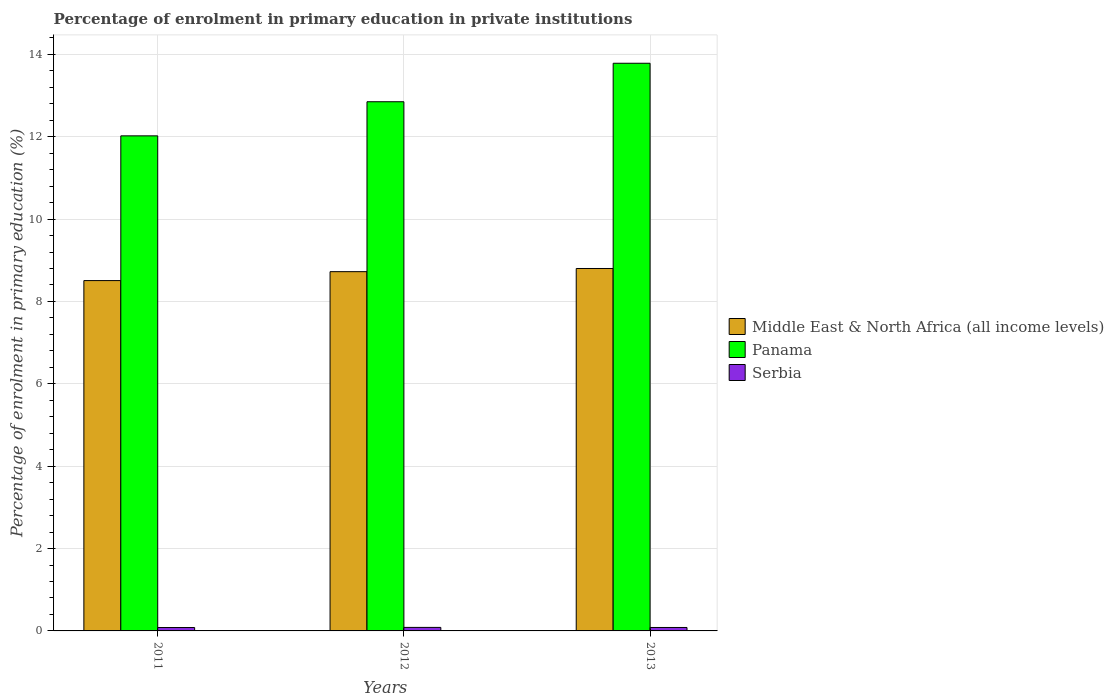How many different coloured bars are there?
Offer a terse response. 3. How many groups of bars are there?
Your answer should be compact. 3. Are the number of bars per tick equal to the number of legend labels?
Your answer should be very brief. Yes. Are the number of bars on each tick of the X-axis equal?
Your answer should be very brief. Yes. How many bars are there on the 1st tick from the left?
Your answer should be compact. 3. What is the label of the 1st group of bars from the left?
Keep it short and to the point. 2011. What is the percentage of enrolment in primary education in Middle East & North Africa (all income levels) in 2012?
Make the answer very short. 8.72. Across all years, what is the maximum percentage of enrolment in primary education in Serbia?
Offer a very short reply. 0.09. Across all years, what is the minimum percentage of enrolment in primary education in Serbia?
Ensure brevity in your answer.  0.08. In which year was the percentage of enrolment in primary education in Serbia minimum?
Offer a terse response. 2011. What is the total percentage of enrolment in primary education in Middle East & North Africa (all income levels) in the graph?
Give a very brief answer. 26.03. What is the difference between the percentage of enrolment in primary education in Middle East & North Africa (all income levels) in 2011 and that in 2013?
Offer a terse response. -0.29. What is the difference between the percentage of enrolment in primary education in Middle East & North Africa (all income levels) in 2011 and the percentage of enrolment in primary education in Serbia in 2012?
Make the answer very short. 8.42. What is the average percentage of enrolment in primary education in Middle East & North Africa (all income levels) per year?
Provide a short and direct response. 8.68. In the year 2013, what is the difference between the percentage of enrolment in primary education in Panama and percentage of enrolment in primary education in Serbia?
Provide a succinct answer. 13.7. In how many years, is the percentage of enrolment in primary education in Middle East & North Africa (all income levels) greater than 2 %?
Ensure brevity in your answer.  3. What is the ratio of the percentage of enrolment in primary education in Serbia in 2012 to that in 2013?
Offer a terse response. 1.02. Is the percentage of enrolment in primary education in Serbia in 2011 less than that in 2013?
Your answer should be compact. Yes. What is the difference between the highest and the second highest percentage of enrolment in primary education in Middle East & North Africa (all income levels)?
Provide a succinct answer. 0.08. What is the difference between the highest and the lowest percentage of enrolment in primary education in Panama?
Provide a short and direct response. 1.76. What does the 1st bar from the left in 2013 represents?
Offer a terse response. Middle East & North Africa (all income levels). What does the 1st bar from the right in 2011 represents?
Make the answer very short. Serbia. Is it the case that in every year, the sum of the percentage of enrolment in primary education in Middle East & North Africa (all income levels) and percentage of enrolment in primary education in Serbia is greater than the percentage of enrolment in primary education in Panama?
Your answer should be very brief. No. How many bars are there?
Your answer should be compact. 9. Are all the bars in the graph horizontal?
Give a very brief answer. No. Are the values on the major ticks of Y-axis written in scientific E-notation?
Make the answer very short. No. Does the graph contain grids?
Offer a very short reply. Yes. How many legend labels are there?
Provide a succinct answer. 3. What is the title of the graph?
Offer a terse response. Percentage of enrolment in primary education in private institutions. What is the label or title of the X-axis?
Provide a short and direct response. Years. What is the label or title of the Y-axis?
Provide a short and direct response. Percentage of enrolment in primary education (%). What is the Percentage of enrolment in primary education (%) in Middle East & North Africa (all income levels) in 2011?
Keep it short and to the point. 8.51. What is the Percentage of enrolment in primary education (%) of Panama in 2011?
Provide a short and direct response. 12.02. What is the Percentage of enrolment in primary education (%) in Serbia in 2011?
Give a very brief answer. 0.08. What is the Percentage of enrolment in primary education (%) in Middle East & North Africa (all income levels) in 2012?
Provide a short and direct response. 8.72. What is the Percentage of enrolment in primary education (%) in Panama in 2012?
Offer a very short reply. 12.85. What is the Percentage of enrolment in primary education (%) of Serbia in 2012?
Your answer should be compact. 0.09. What is the Percentage of enrolment in primary education (%) in Middle East & North Africa (all income levels) in 2013?
Make the answer very short. 8.8. What is the Percentage of enrolment in primary education (%) of Panama in 2013?
Your response must be concise. 13.78. What is the Percentage of enrolment in primary education (%) of Serbia in 2013?
Keep it short and to the point. 0.08. Across all years, what is the maximum Percentage of enrolment in primary education (%) in Middle East & North Africa (all income levels)?
Ensure brevity in your answer.  8.8. Across all years, what is the maximum Percentage of enrolment in primary education (%) in Panama?
Your response must be concise. 13.78. Across all years, what is the maximum Percentage of enrolment in primary education (%) of Serbia?
Your answer should be compact. 0.09. Across all years, what is the minimum Percentage of enrolment in primary education (%) in Middle East & North Africa (all income levels)?
Make the answer very short. 8.51. Across all years, what is the minimum Percentage of enrolment in primary education (%) in Panama?
Your response must be concise. 12.02. Across all years, what is the minimum Percentage of enrolment in primary education (%) in Serbia?
Provide a succinct answer. 0.08. What is the total Percentage of enrolment in primary education (%) in Middle East & North Africa (all income levels) in the graph?
Your response must be concise. 26.03. What is the total Percentage of enrolment in primary education (%) in Panama in the graph?
Provide a short and direct response. 38.65. What is the total Percentage of enrolment in primary education (%) in Serbia in the graph?
Keep it short and to the point. 0.25. What is the difference between the Percentage of enrolment in primary education (%) in Middle East & North Africa (all income levels) in 2011 and that in 2012?
Make the answer very short. -0.22. What is the difference between the Percentage of enrolment in primary education (%) in Panama in 2011 and that in 2012?
Offer a terse response. -0.83. What is the difference between the Percentage of enrolment in primary education (%) in Serbia in 2011 and that in 2012?
Offer a terse response. -0. What is the difference between the Percentage of enrolment in primary education (%) in Middle East & North Africa (all income levels) in 2011 and that in 2013?
Provide a short and direct response. -0.29. What is the difference between the Percentage of enrolment in primary education (%) of Panama in 2011 and that in 2013?
Your answer should be compact. -1.76. What is the difference between the Percentage of enrolment in primary education (%) of Serbia in 2011 and that in 2013?
Offer a terse response. -0. What is the difference between the Percentage of enrolment in primary education (%) of Middle East & North Africa (all income levels) in 2012 and that in 2013?
Ensure brevity in your answer.  -0.08. What is the difference between the Percentage of enrolment in primary education (%) in Panama in 2012 and that in 2013?
Provide a succinct answer. -0.93. What is the difference between the Percentage of enrolment in primary education (%) in Serbia in 2012 and that in 2013?
Offer a very short reply. 0. What is the difference between the Percentage of enrolment in primary education (%) of Middle East & North Africa (all income levels) in 2011 and the Percentage of enrolment in primary education (%) of Panama in 2012?
Make the answer very short. -4.34. What is the difference between the Percentage of enrolment in primary education (%) in Middle East & North Africa (all income levels) in 2011 and the Percentage of enrolment in primary education (%) in Serbia in 2012?
Keep it short and to the point. 8.42. What is the difference between the Percentage of enrolment in primary education (%) in Panama in 2011 and the Percentage of enrolment in primary education (%) in Serbia in 2012?
Provide a succinct answer. 11.93. What is the difference between the Percentage of enrolment in primary education (%) in Middle East & North Africa (all income levels) in 2011 and the Percentage of enrolment in primary education (%) in Panama in 2013?
Your response must be concise. -5.28. What is the difference between the Percentage of enrolment in primary education (%) in Middle East & North Africa (all income levels) in 2011 and the Percentage of enrolment in primary education (%) in Serbia in 2013?
Ensure brevity in your answer.  8.42. What is the difference between the Percentage of enrolment in primary education (%) in Panama in 2011 and the Percentage of enrolment in primary education (%) in Serbia in 2013?
Provide a succinct answer. 11.94. What is the difference between the Percentage of enrolment in primary education (%) in Middle East & North Africa (all income levels) in 2012 and the Percentage of enrolment in primary education (%) in Panama in 2013?
Offer a very short reply. -5.06. What is the difference between the Percentage of enrolment in primary education (%) of Middle East & North Africa (all income levels) in 2012 and the Percentage of enrolment in primary education (%) of Serbia in 2013?
Provide a short and direct response. 8.64. What is the difference between the Percentage of enrolment in primary education (%) of Panama in 2012 and the Percentage of enrolment in primary education (%) of Serbia in 2013?
Make the answer very short. 12.77. What is the average Percentage of enrolment in primary education (%) of Middle East & North Africa (all income levels) per year?
Ensure brevity in your answer.  8.68. What is the average Percentage of enrolment in primary education (%) of Panama per year?
Your answer should be compact. 12.88. What is the average Percentage of enrolment in primary education (%) of Serbia per year?
Give a very brief answer. 0.08. In the year 2011, what is the difference between the Percentage of enrolment in primary education (%) of Middle East & North Africa (all income levels) and Percentage of enrolment in primary education (%) of Panama?
Offer a very short reply. -3.51. In the year 2011, what is the difference between the Percentage of enrolment in primary education (%) in Middle East & North Africa (all income levels) and Percentage of enrolment in primary education (%) in Serbia?
Your answer should be compact. 8.42. In the year 2011, what is the difference between the Percentage of enrolment in primary education (%) of Panama and Percentage of enrolment in primary education (%) of Serbia?
Offer a very short reply. 11.94. In the year 2012, what is the difference between the Percentage of enrolment in primary education (%) of Middle East & North Africa (all income levels) and Percentage of enrolment in primary education (%) of Panama?
Make the answer very short. -4.13. In the year 2012, what is the difference between the Percentage of enrolment in primary education (%) in Middle East & North Africa (all income levels) and Percentage of enrolment in primary education (%) in Serbia?
Provide a succinct answer. 8.64. In the year 2012, what is the difference between the Percentage of enrolment in primary education (%) in Panama and Percentage of enrolment in primary education (%) in Serbia?
Offer a terse response. 12.76. In the year 2013, what is the difference between the Percentage of enrolment in primary education (%) in Middle East & North Africa (all income levels) and Percentage of enrolment in primary education (%) in Panama?
Your response must be concise. -4.98. In the year 2013, what is the difference between the Percentage of enrolment in primary education (%) of Middle East & North Africa (all income levels) and Percentage of enrolment in primary education (%) of Serbia?
Your answer should be very brief. 8.72. In the year 2013, what is the difference between the Percentage of enrolment in primary education (%) of Panama and Percentage of enrolment in primary education (%) of Serbia?
Give a very brief answer. 13.7. What is the ratio of the Percentage of enrolment in primary education (%) of Middle East & North Africa (all income levels) in 2011 to that in 2012?
Give a very brief answer. 0.98. What is the ratio of the Percentage of enrolment in primary education (%) in Panama in 2011 to that in 2012?
Provide a succinct answer. 0.94. What is the ratio of the Percentage of enrolment in primary education (%) in Serbia in 2011 to that in 2012?
Your response must be concise. 0.96. What is the ratio of the Percentage of enrolment in primary education (%) in Middle East & North Africa (all income levels) in 2011 to that in 2013?
Ensure brevity in your answer.  0.97. What is the ratio of the Percentage of enrolment in primary education (%) of Panama in 2011 to that in 2013?
Keep it short and to the point. 0.87. What is the ratio of the Percentage of enrolment in primary education (%) in Serbia in 2011 to that in 2013?
Your answer should be compact. 0.99. What is the ratio of the Percentage of enrolment in primary education (%) of Middle East & North Africa (all income levels) in 2012 to that in 2013?
Your answer should be very brief. 0.99. What is the ratio of the Percentage of enrolment in primary education (%) in Panama in 2012 to that in 2013?
Provide a succinct answer. 0.93. What is the ratio of the Percentage of enrolment in primary education (%) in Serbia in 2012 to that in 2013?
Provide a short and direct response. 1.02. What is the difference between the highest and the second highest Percentage of enrolment in primary education (%) of Middle East & North Africa (all income levels)?
Provide a short and direct response. 0.08. What is the difference between the highest and the second highest Percentage of enrolment in primary education (%) of Panama?
Keep it short and to the point. 0.93. What is the difference between the highest and the second highest Percentage of enrolment in primary education (%) of Serbia?
Ensure brevity in your answer.  0. What is the difference between the highest and the lowest Percentage of enrolment in primary education (%) in Middle East & North Africa (all income levels)?
Keep it short and to the point. 0.29. What is the difference between the highest and the lowest Percentage of enrolment in primary education (%) in Panama?
Offer a terse response. 1.76. What is the difference between the highest and the lowest Percentage of enrolment in primary education (%) of Serbia?
Offer a terse response. 0. 